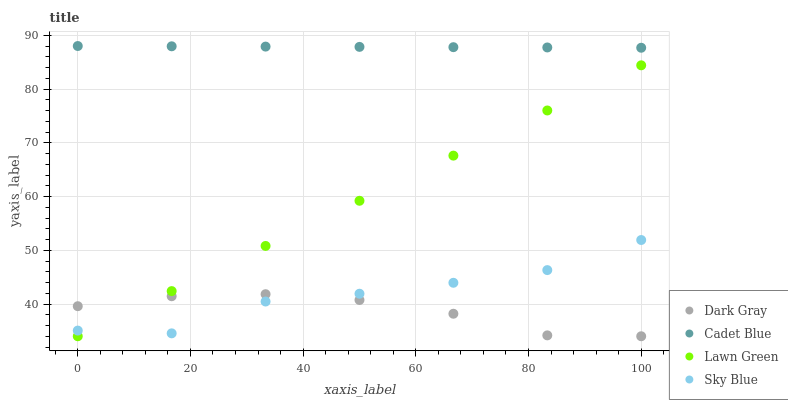Does Dark Gray have the minimum area under the curve?
Answer yes or no. Yes. Does Cadet Blue have the maximum area under the curve?
Answer yes or no. Yes. Does Lawn Green have the minimum area under the curve?
Answer yes or no. No. Does Lawn Green have the maximum area under the curve?
Answer yes or no. No. Is Cadet Blue the smoothest?
Answer yes or no. Yes. Is Sky Blue the roughest?
Answer yes or no. Yes. Is Lawn Green the smoothest?
Answer yes or no. No. Is Lawn Green the roughest?
Answer yes or no. No. Does Dark Gray have the lowest value?
Answer yes or no. Yes. Does Cadet Blue have the lowest value?
Answer yes or no. No. Does Cadet Blue have the highest value?
Answer yes or no. Yes. Does Lawn Green have the highest value?
Answer yes or no. No. Is Lawn Green less than Cadet Blue?
Answer yes or no. Yes. Is Cadet Blue greater than Dark Gray?
Answer yes or no. Yes. Does Sky Blue intersect Lawn Green?
Answer yes or no. Yes. Is Sky Blue less than Lawn Green?
Answer yes or no. No. Is Sky Blue greater than Lawn Green?
Answer yes or no. No. Does Lawn Green intersect Cadet Blue?
Answer yes or no. No. 